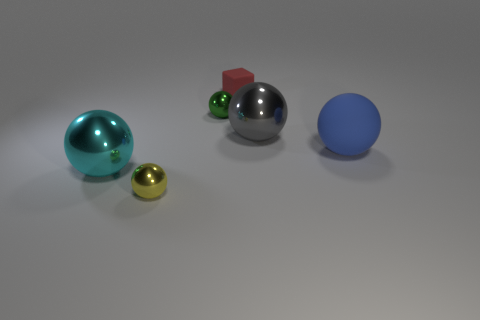Are there an equal number of large rubber balls behind the big gray metallic ball and green metallic objects that are in front of the small yellow sphere?
Ensure brevity in your answer.  Yes. How many other things are there of the same material as the tiny red object?
Keep it short and to the point. 1. How many metal things are either yellow spheres or small green things?
Provide a succinct answer. 2. There is a matte thing that is to the right of the small cube; is its shape the same as the big cyan metal thing?
Your answer should be compact. Yes. Is the number of green spheres that are in front of the cube greater than the number of big red rubber blocks?
Ensure brevity in your answer.  Yes. How many things are both in front of the red thing and to the right of the green metal thing?
Ensure brevity in your answer.  2. What color is the large shiny object that is left of the shiny object that is to the right of the red matte cube?
Your answer should be very brief. Cyan. How many metal spheres are the same color as the large rubber object?
Your answer should be very brief. 0. Is the number of big gray metallic spheres less than the number of large spheres?
Provide a short and direct response. Yes. Are there more big rubber balls that are behind the yellow shiny thing than big blue balls that are behind the large gray metal thing?
Make the answer very short. Yes. 